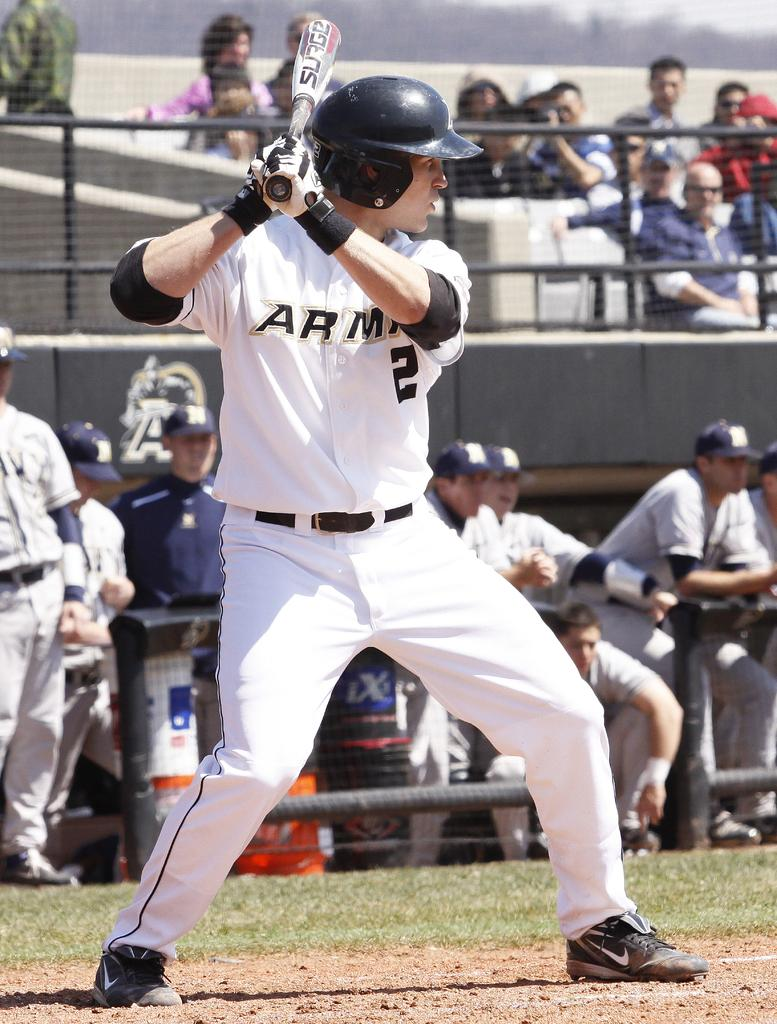<image>
Create a compact narrative representing the image presented. A batter in a Army jersey with the number 2 on it. 